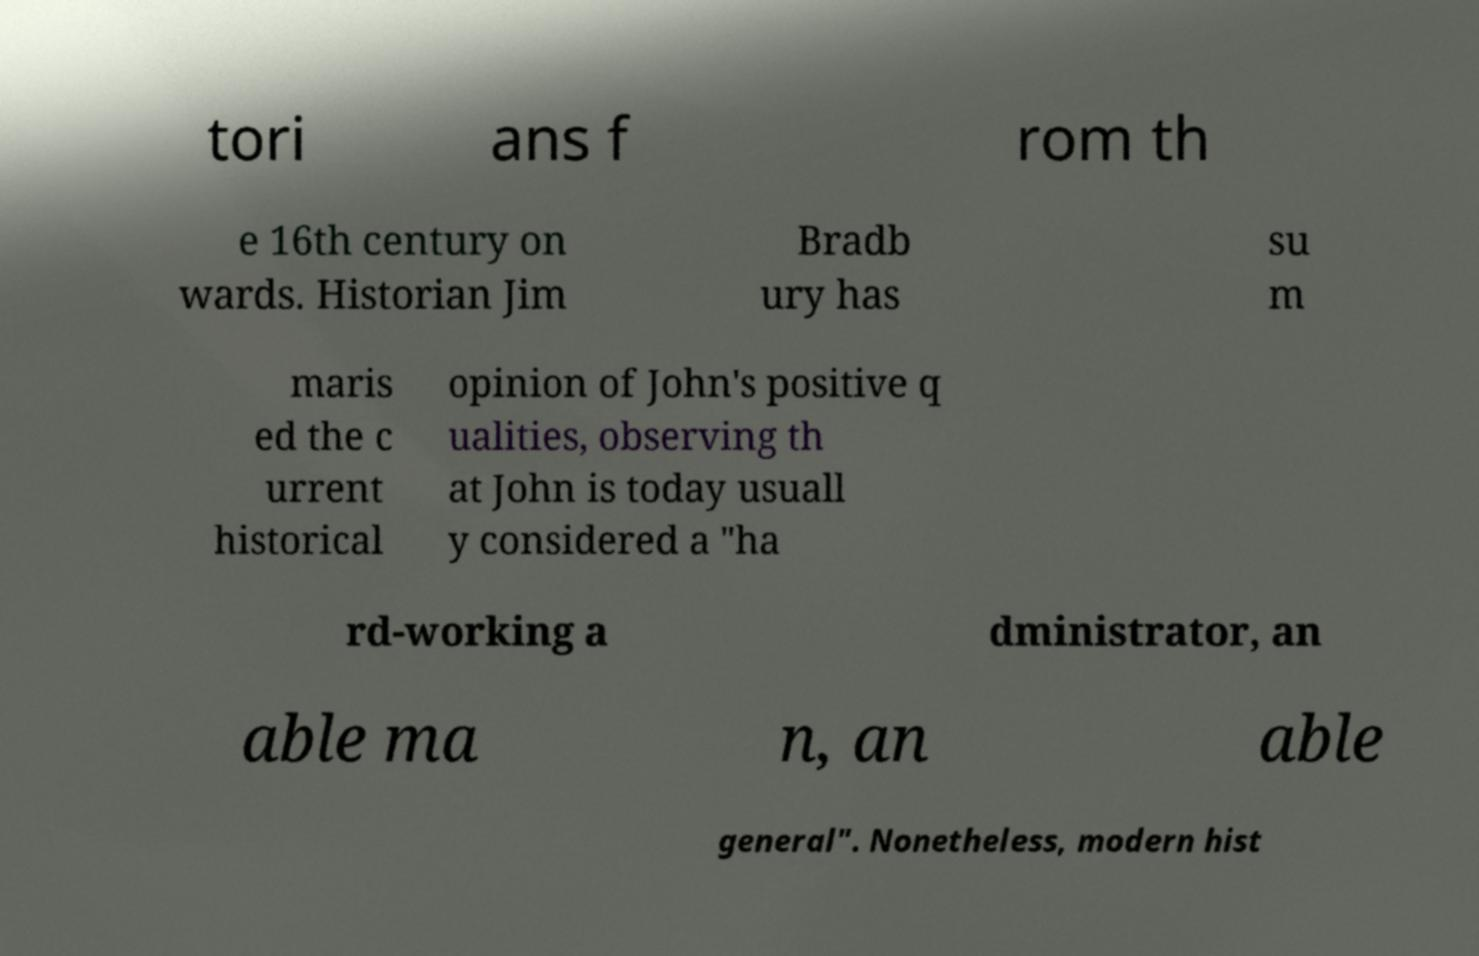Could you extract and type out the text from this image? tori ans f rom th e 16th century on wards. Historian Jim Bradb ury has su m maris ed the c urrent historical opinion of John's positive q ualities, observing th at John is today usuall y considered a "ha rd-working a dministrator, an able ma n, an able general". Nonetheless, modern hist 